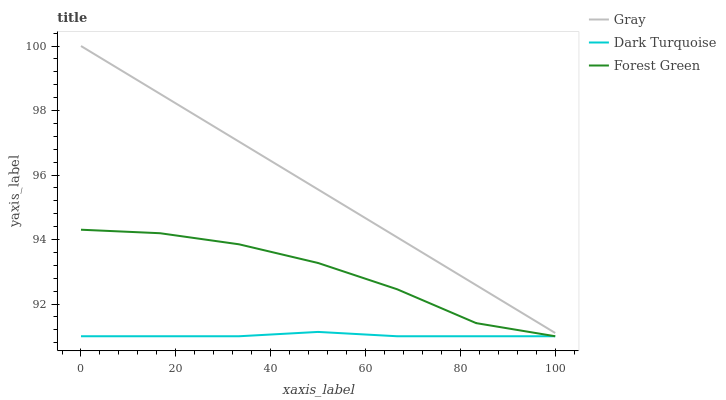Does Forest Green have the minimum area under the curve?
Answer yes or no. No. Does Forest Green have the maximum area under the curve?
Answer yes or no. No. Is Dark Turquoise the smoothest?
Answer yes or no. No. Is Dark Turquoise the roughest?
Answer yes or no. No. Does Forest Green have the highest value?
Answer yes or no. No. Is Dark Turquoise less than Gray?
Answer yes or no. Yes. Is Gray greater than Forest Green?
Answer yes or no. Yes. Does Dark Turquoise intersect Gray?
Answer yes or no. No. 